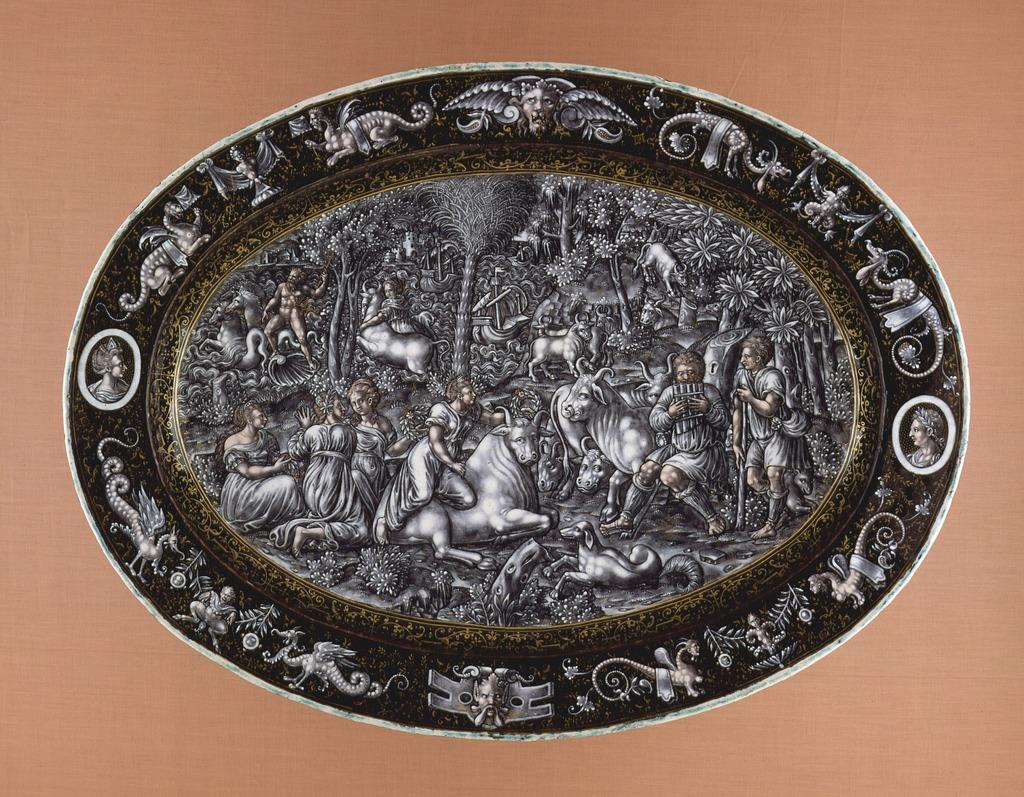What type of object is present in the image that contains sculptures? There is an object with sculptures in the image. What kind of creatures are depicted in the sculptures? The sculptures include dragons. What other subjects are included in the sculptures? The sculptures include humans, bulls, and trees. What type of glass is used to create the sculptures in the image? There is no mention of glass being used to create the sculptures in the image. The sculptures are made of a material that is not specified in the provided facts. 